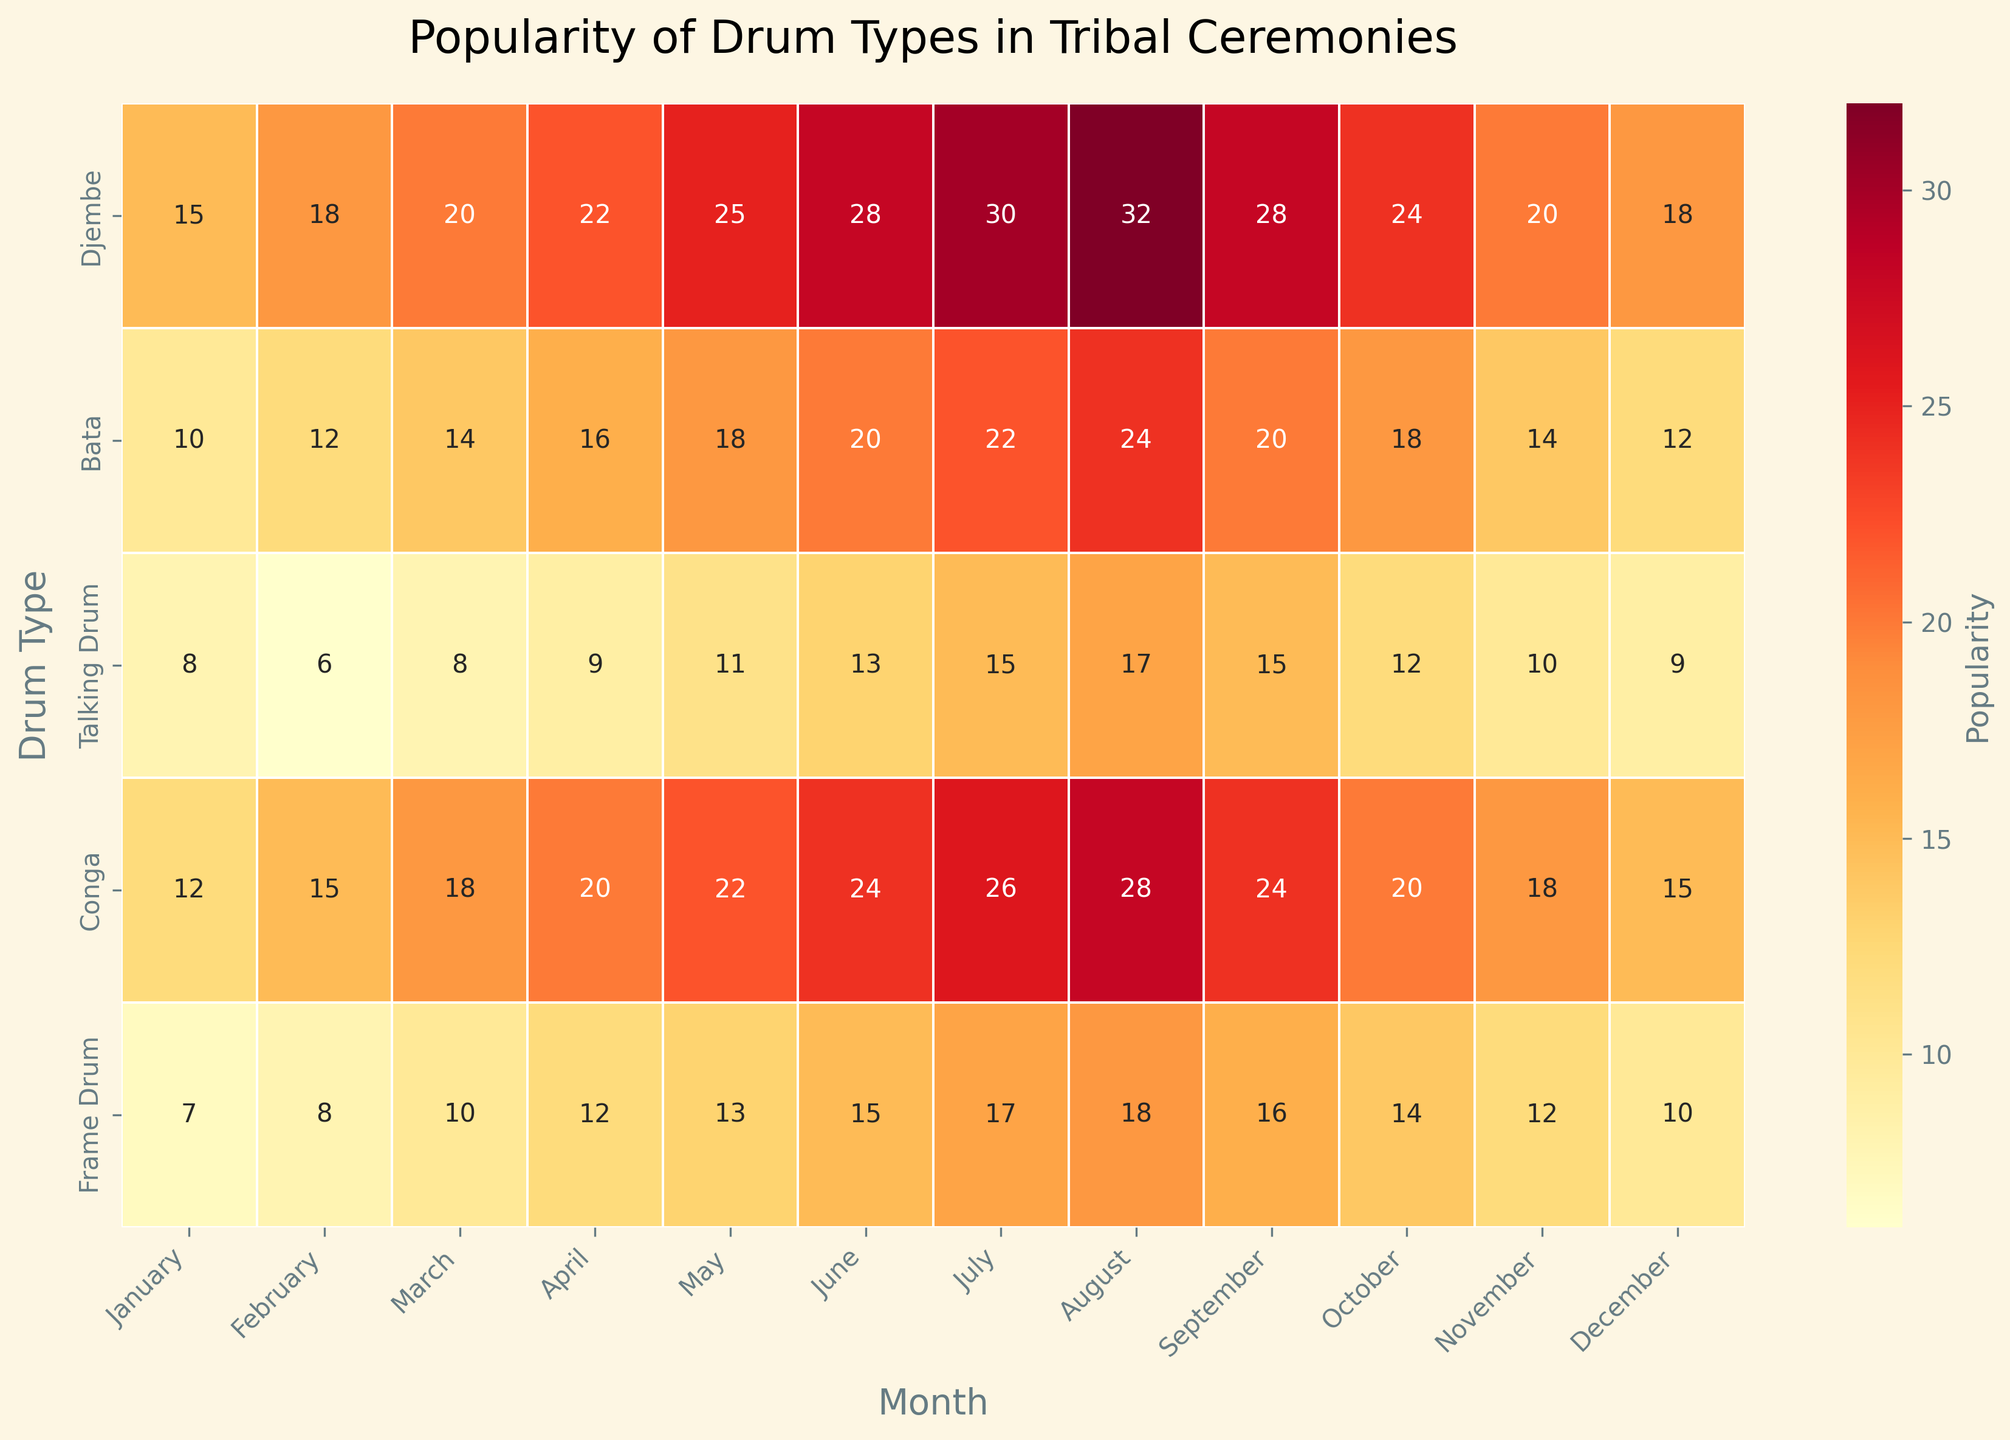Which month shows the highest popularity for the Djembe drum? Look for the row corresponding to the 'Djembe' drum and find the month with the highest value in that row. The highest value in the Djembe row is 32, which occurs in August.
Answer: August Which drum type has the lowest popularity in April? Check the vertical column for April and identify the drum with the smallest number. In April, the values are 22, 16, 9, 20, 12, and the smallest is 9 for the Talking Drum.
Answer: Talking Drum What is the average popularity of the Conga drum across the year? The values for the Conga drum are 12, 15, 18, 20, 22, 24, 26, 28, 24, 20, 18, and 15. Sum these values (15+18+20+22+24+26+28+32+24+20+18+15 = 262) and then divide by 12 (the number of months). The average is 262/12 ≈ 21.83.
Answer: 21.83 Which month shows the least popularity across all drum types? To find the month with the lowest total popularity, sum up the popularity values for each month and then compare these totals. January: 52, February: 59, March: 70, April: 79, May: 89, June: 100, July: 110, August: 119, September: 103, October: 88, November: 74, December: 64. The lowest total is in January.
Answer: January Compare the popularity of the Frame Drum in January and December. Which month has higher popularity? Check the values for the Frame Drum in January and December. In January, it's 7, and in December, it's 10. Since 10 is greater than 7, December has higher popularity.
Answer: December What is the total popularity of all drum types in July? Sum the values for all drum types in July: 30 (Djembe), 22 (Bata), 15 (Talking Drum), 26 (Conga), and 17 (Frame Drum). The total is 30 + 22 + 15 + 26 + 17 = 110.
Answer: 110 Which drum type shows the most increase in popularity from January to July? Calculate the difference in popularity from January to July for each drum type: 
Djembe: 30 - 15 = 15
Bata: 22 - 10 = 12
Talking Drum: 15 - 8 = 7
Conga: 26 - 12 = 14
Frame Drum: 17 - 7 = 10
The most significant increase is for Djembe, with 15.
Answer: Djembe Evaluate the popularity trend of the Bata drum from April to October. Is it increasing, decreasing, or stable? Check the values for the Bata drum from April to October: 16, 18, 20, 22, 20, and 18. The values are initially increasing (16 to 22) and then decreasing (22 to 18), showing a peak in July.
Answer: Increasing then decreasing What's the range of popularity values for the Talking Drum throughout the year? Identify the highest and lowest values for the Talking Drum: the highest value is 17 (in August) and the lowest is 6 (in February). The range is 17 - 6 = 11.
Answer: 11 